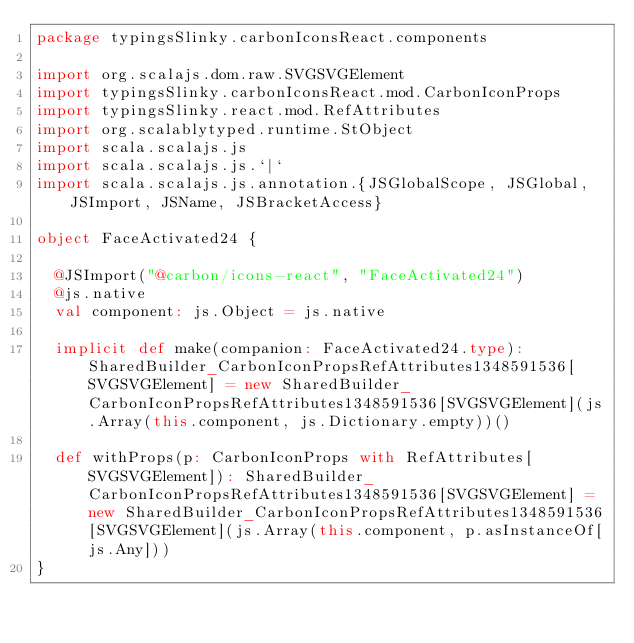Convert code to text. <code><loc_0><loc_0><loc_500><loc_500><_Scala_>package typingsSlinky.carbonIconsReact.components

import org.scalajs.dom.raw.SVGSVGElement
import typingsSlinky.carbonIconsReact.mod.CarbonIconProps
import typingsSlinky.react.mod.RefAttributes
import org.scalablytyped.runtime.StObject
import scala.scalajs.js
import scala.scalajs.js.`|`
import scala.scalajs.js.annotation.{JSGlobalScope, JSGlobal, JSImport, JSName, JSBracketAccess}

object FaceActivated24 {
  
  @JSImport("@carbon/icons-react", "FaceActivated24")
  @js.native
  val component: js.Object = js.native
  
  implicit def make(companion: FaceActivated24.type): SharedBuilder_CarbonIconPropsRefAttributes1348591536[SVGSVGElement] = new SharedBuilder_CarbonIconPropsRefAttributes1348591536[SVGSVGElement](js.Array(this.component, js.Dictionary.empty))()
  
  def withProps(p: CarbonIconProps with RefAttributes[SVGSVGElement]): SharedBuilder_CarbonIconPropsRefAttributes1348591536[SVGSVGElement] = new SharedBuilder_CarbonIconPropsRefAttributes1348591536[SVGSVGElement](js.Array(this.component, p.asInstanceOf[js.Any]))
}
</code> 